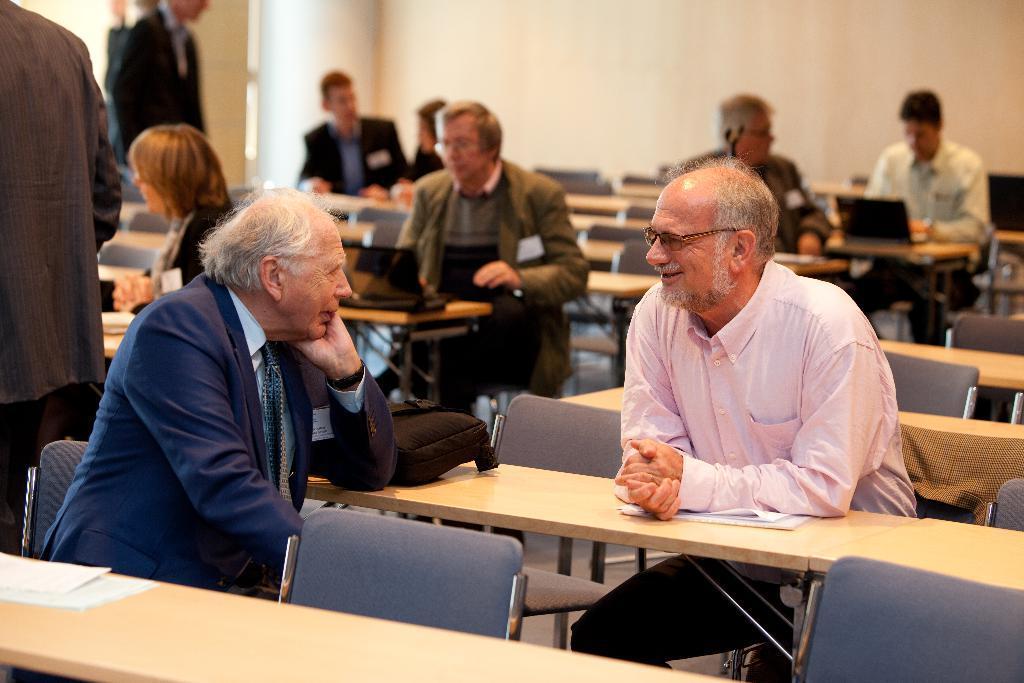In one or two sentences, can you explain what this image depicts? In this image I can see number of people are sitting on chairs. I can also see smile on his face and he is wearing a specs. I can also see number of benches and on this bench I can see few papers. 